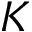<formula> <loc_0><loc_0><loc_500><loc_500>K</formula> 